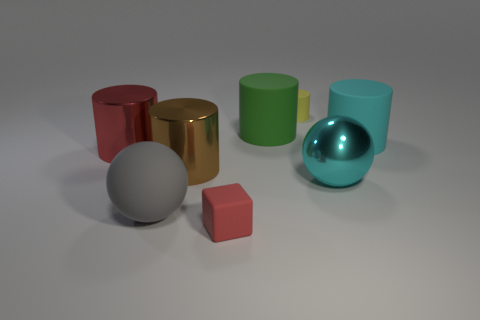Is there any other thing that has the same shape as the red matte thing?
Give a very brief answer. No. Is the size of the rubber ball that is to the left of the cyan matte object the same as the yellow cylinder behind the brown shiny object?
Your answer should be compact. No. There is a sphere that is to the right of the green cylinder on the left side of the tiny matte cylinder; what is its size?
Ensure brevity in your answer.  Large. How many cylinders are either big blue matte things or big metal things?
Provide a succinct answer. 2. There is a green cylinder that is made of the same material as the small yellow cylinder; what is its size?
Your response must be concise. Large. How many big balls are the same color as the block?
Provide a short and direct response. 0. There is a tiny cylinder; are there any green matte things to the left of it?
Your answer should be compact. Yes. There is a yellow object; is it the same shape as the big matte object that is on the right side of the yellow cylinder?
Ensure brevity in your answer.  Yes. What number of things are either small red blocks that are in front of the matte sphere or tiny red rubber things?
Provide a succinct answer. 1. How many red things are both in front of the large brown thing and on the left side of the big brown metal cylinder?
Make the answer very short. 0. 